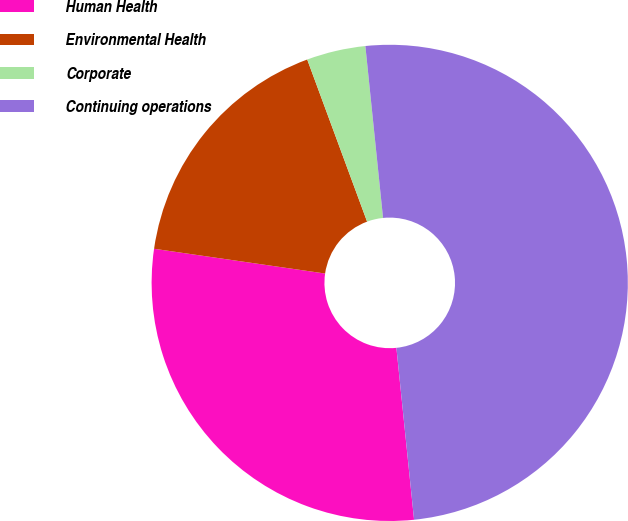Convert chart. <chart><loc_0><loc_0><loc_500><loc_500><pie_chart><fcel>Human Health<fcel>Environmental Health<fcel>Corporate<fcel>Continuing operations<nl><fcel>28.92%<fcel>17.08%<fcel>4.0%<fcel>50.0%<nl></chart> 